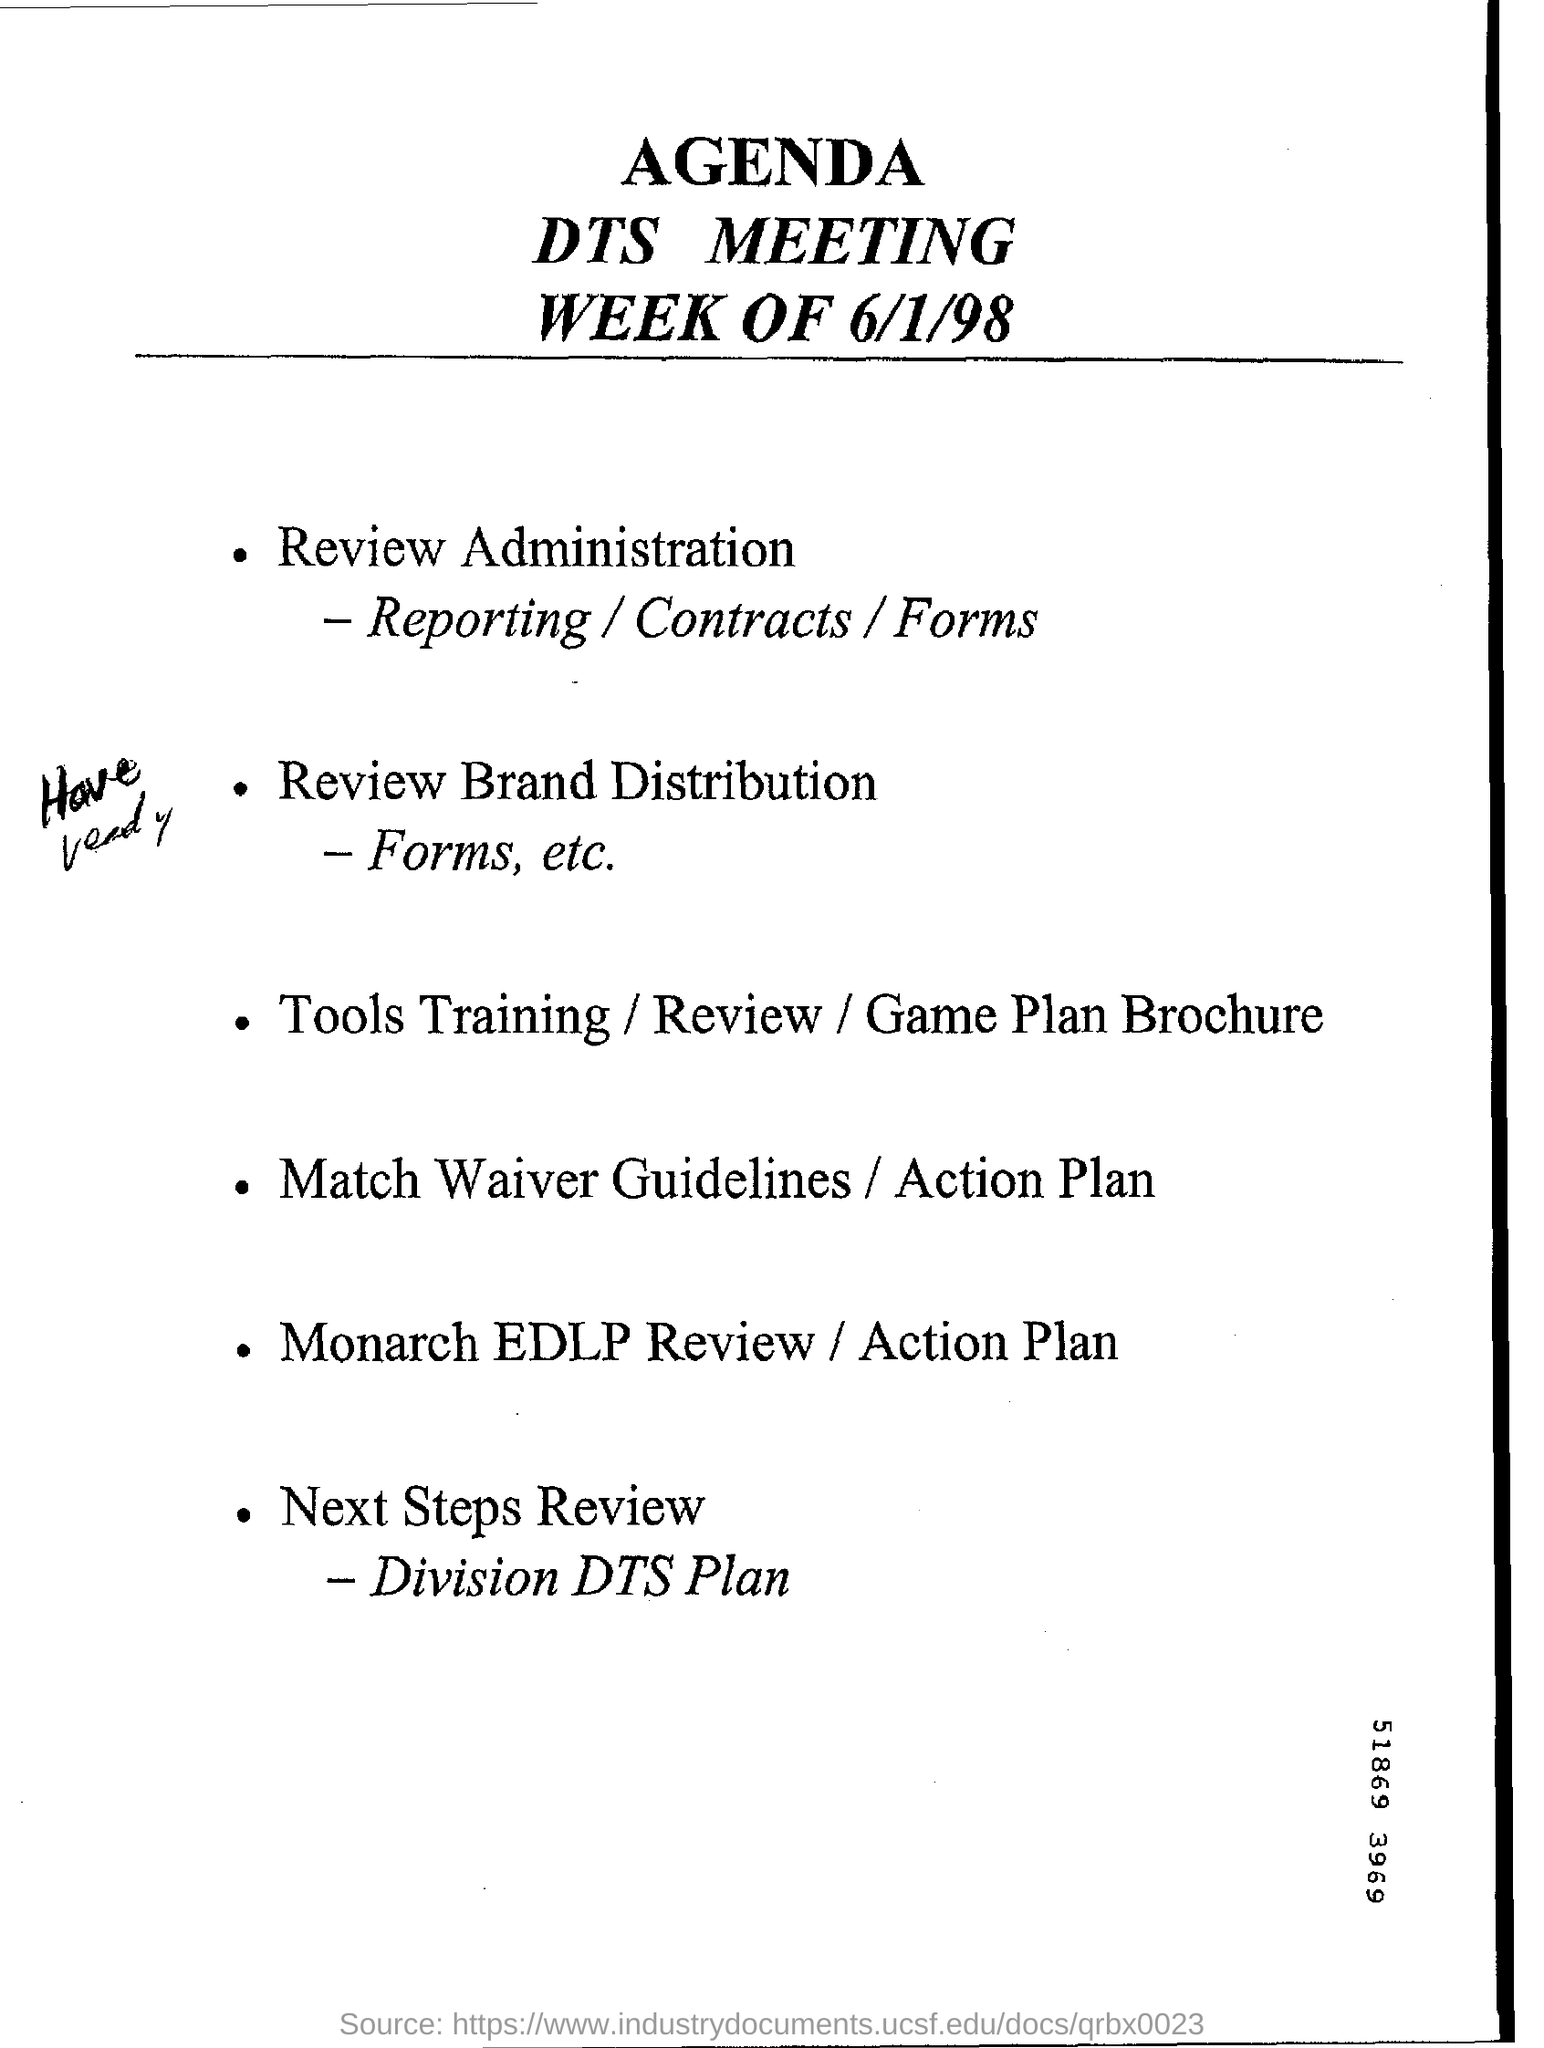Highlight a few significant elements in this photo. The document provided contains the agenda for a meeting titled 'DTS MEETING.' The date mentioned in this document is 6/1/98. 